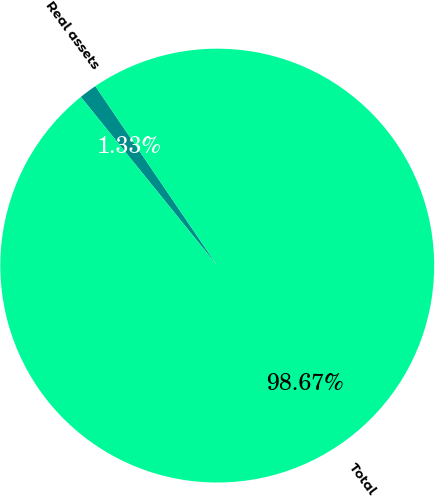<chart> <loc_0><loc_0><loc_500><loc_500><pie_chart><fcel>Real assets<fcel>Total<nl><fcel>1.33%<fcel>98.67%<nl></chart> 